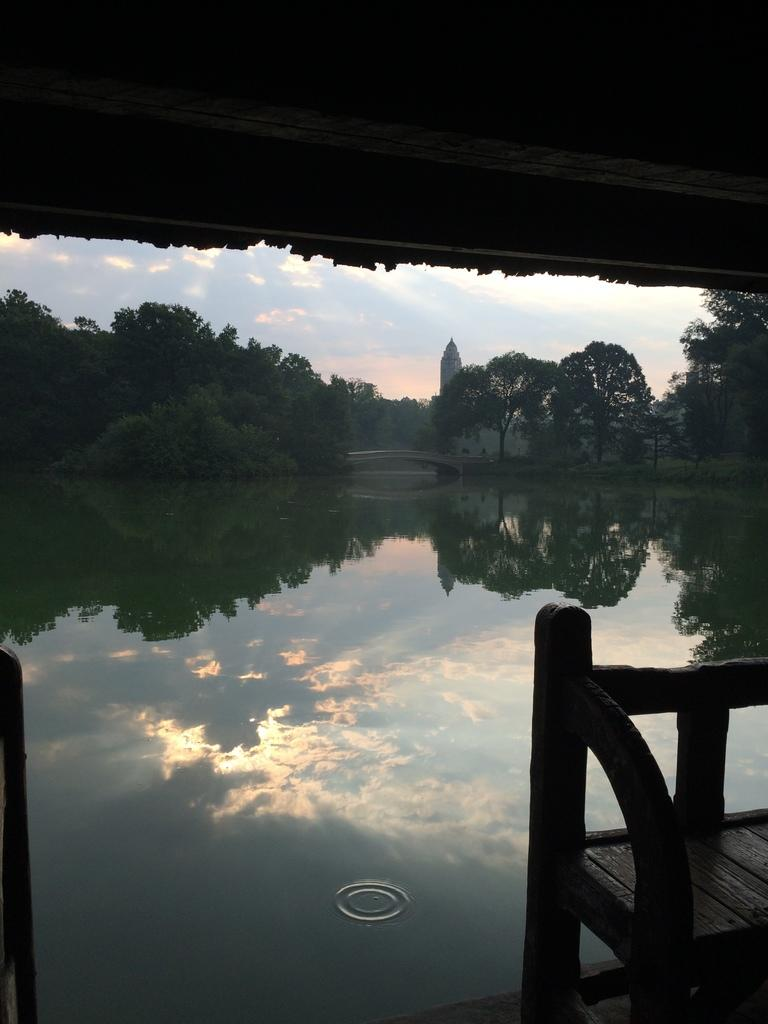What type of boundary can be seen in the image? There is a wooden boundary in the image. What structure is visible above the boundary? There is a roof in the image. What is in the foreground of the image? There is a water surface in the foreground of the image. What can be seen in the background of the image? There are trees and a tower in the background of the image. What else is visible in the background of the image? The sky is visible in the background of the image. How many beggars are visible in the image? There are no beggars present in the image. What type of net is being used to catch fish in the image? There is no net present in the image, and no fishing activity is depicted. 